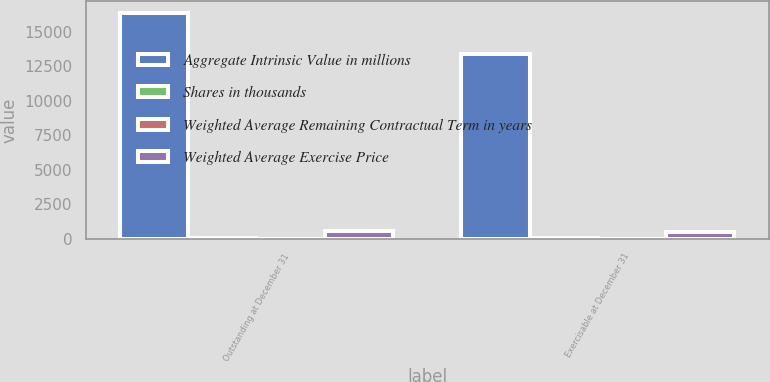Convert chart to OTSL. <chart><loc_0><loc_0><loc_500><loc_500><stacked_bar_chart><ecel><fcel>Outstanding at December 31<fcel>Exercisable at December 31<nl><fcel>Aggregate Intrinsic Value in millions<fcel>16368<fcel>13409<nl><fcel>Shares in thousands<fcel>48.94<fcel>46.48<nl><fcel>Weighted Average Remaining Contractual Term in years<fcel>5.1<fcel>4.4<nl><fcel>Weighted Average Exercise Price<fcel>528<fcel>466<nl></chart> 